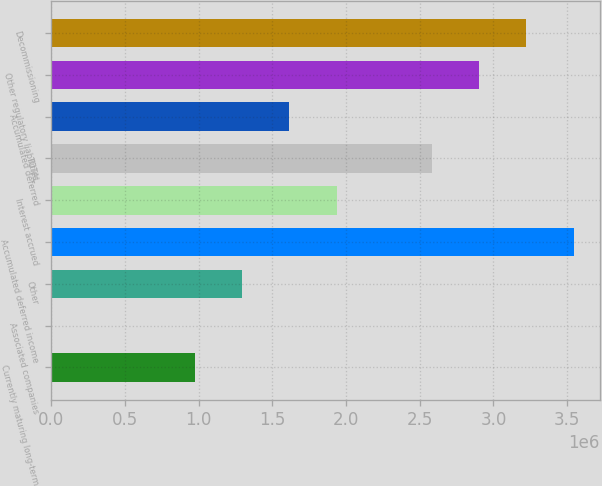<chart> <loc_0><loc_0><loc_500><loc_500><bar_chart><fcel>Currently maturing long-term<fcel>Associated companies<fcel>Other<fcel>Accumulated deferred income<fcel>Interest accrued<fcel>TOTAL<fcel>Accumulated deferred<fcel>Other regulatory liabilities<fcel>Decommissioning<nl><fcel>971785<fcel>6520<fcel>1.29354e+06<fcel>3.54582e+06<fcel>1.93705e+06<fcel>2.58056e+06<fcel>1.6153e+06<fcel>2.90232e+06<fcel>3.22407e+06<nl></chart> 